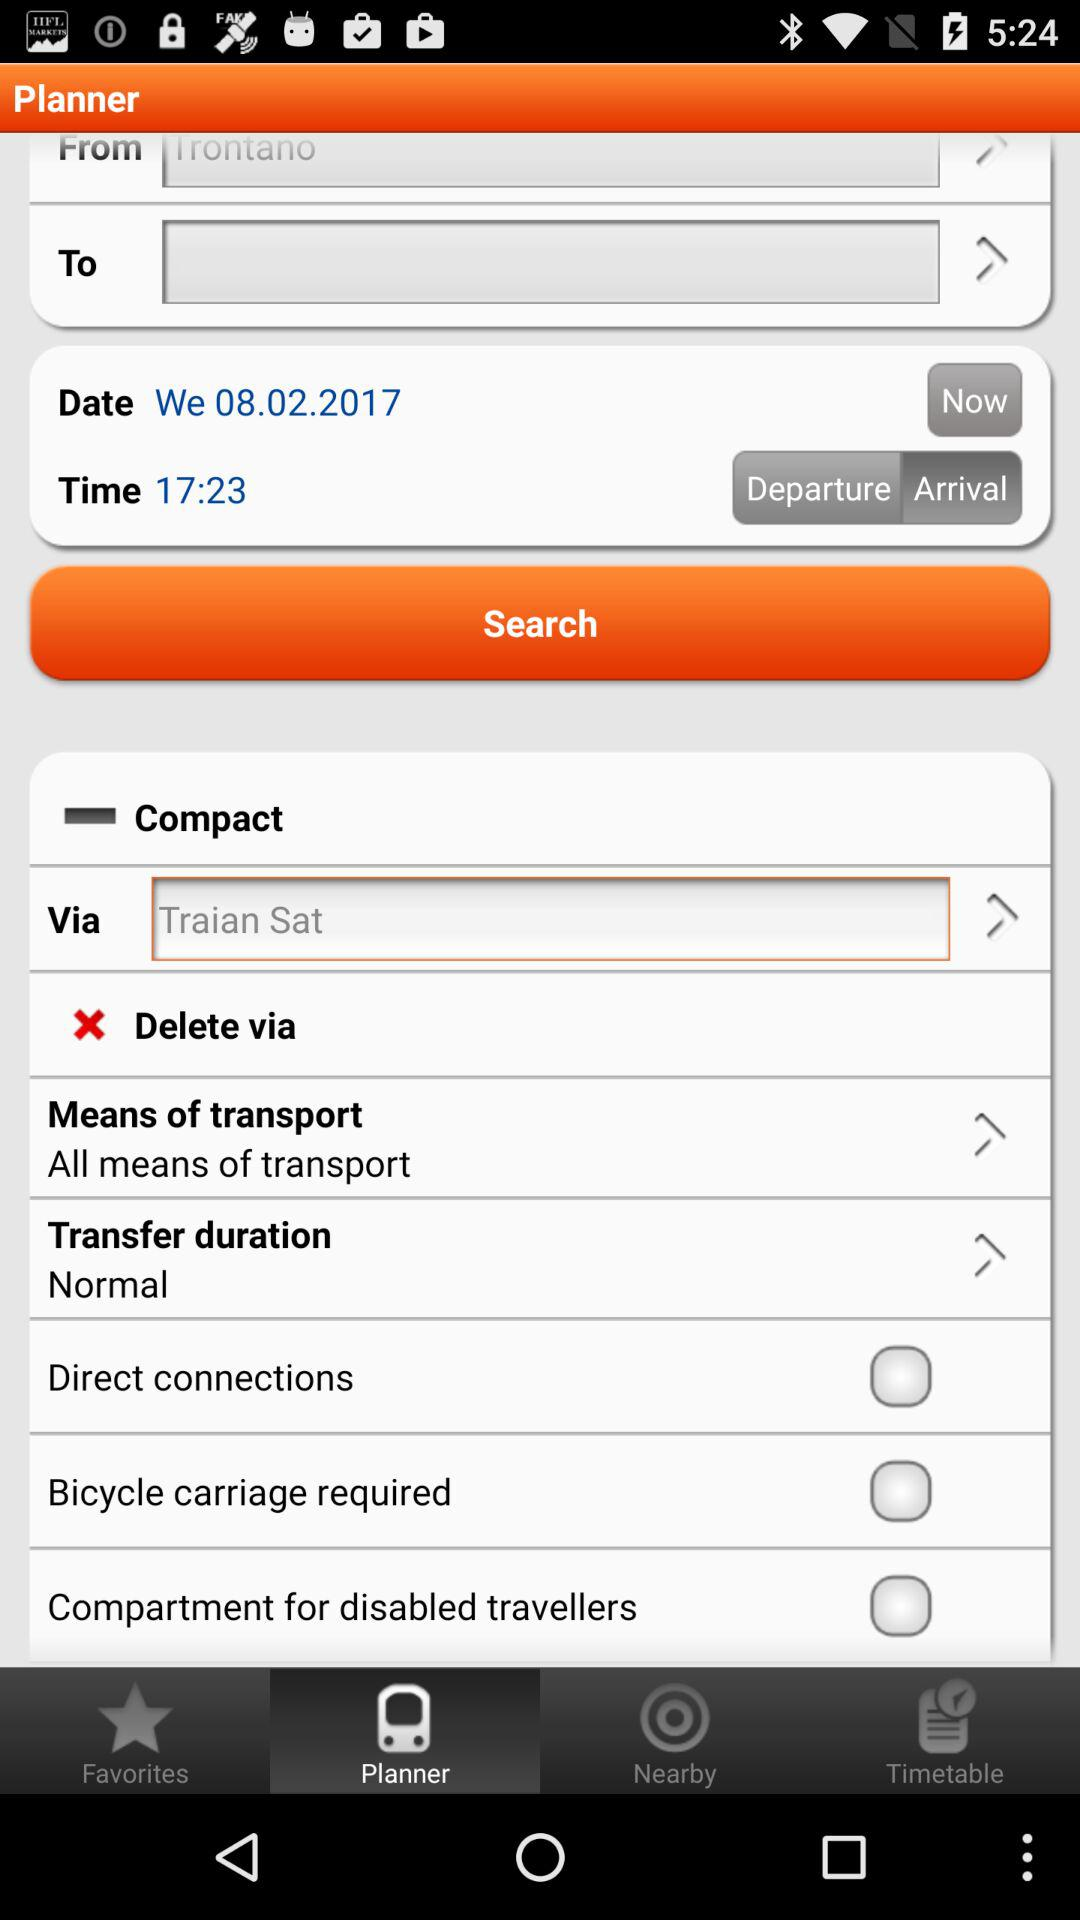What is the status of "Bicycle carriage required"? The status is "off". 